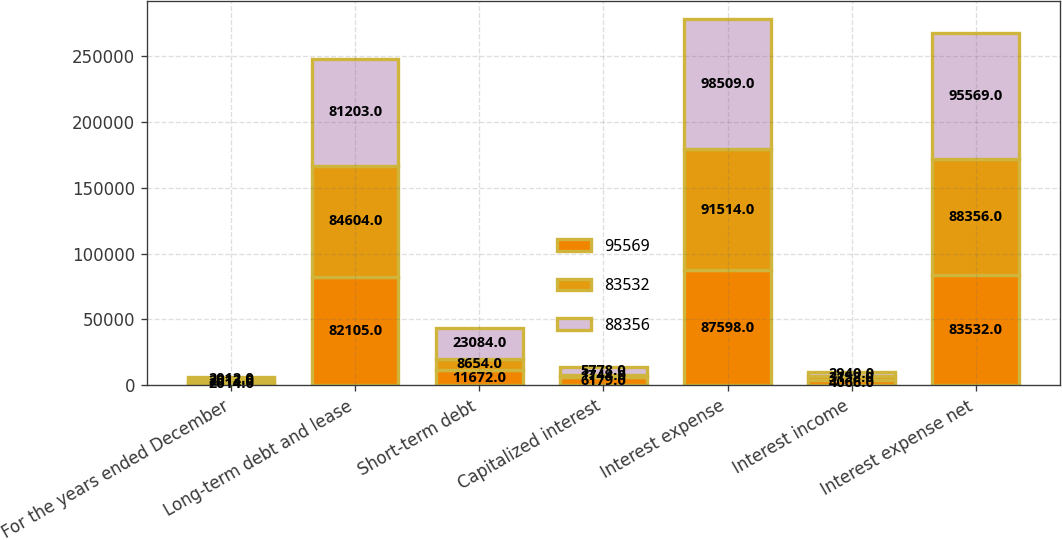Convert chart to OTSL. <chart><loc_0><loc_0><loc_500><loc_500><stacked_bar_chart><ecel><fcel>For the years ended December<fcel>Long-term debt and lease<fcel>Short-term debt<fcel>Capitalized interest<fcel>Interest expense<fcel>Interest income<fcel>Interest expense net<nl><fcel>95569<fcel>2014<fcel>82105<fcel>11672<fcel>6179<fcel>87598<fcel>4066<fcel>83532<nl><fcel>83532<fcel>2013<fcel>84604<fcel>8654<fcel>1744<fcel>91514<fcel>3158<fcel>88356<nl><fcel>88356<fcel>2012<fcel>81203<fcel>23084<fcel>5778<fcel>98509<fcel>2940<fcel>95569<nl></chart> 